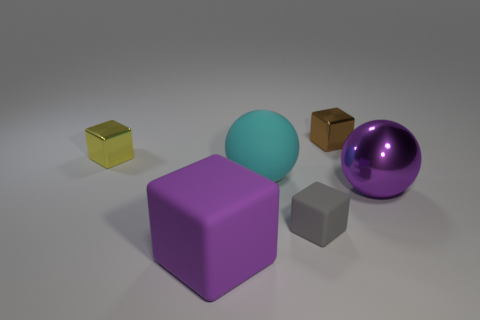Add 2 yellow shiny objects. How many objects exist? 8 Subtract all spheres. How many objects are left? 4 Add 5 big cyan objects. How many big cyan objects are left? 6 Add 2 small blue matte balls. How many small blue matte balls exist? 2 Subtract 0 green cylinders. How many objects are left? 6 Subtract all yellow cubes. Subtract all big metal objects. How many objects are left? 4 